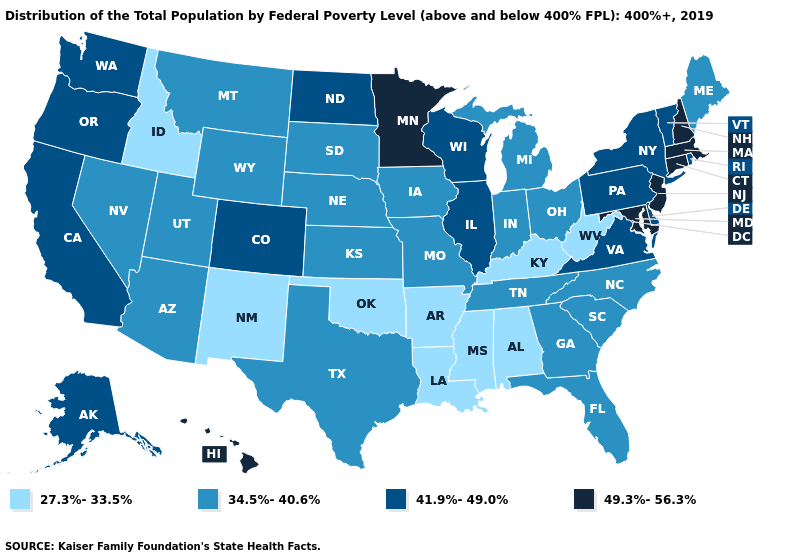Which states have the lowest value in the USA?
Keep it brief. Alabama, Arkansas, Idaho, Kentucky, Louisiana, Mississippi, New Mexico, Oklahoma, West Virginia. What is the lowest value in states that border Utah?
Give a very brief answer. 27.3%-33.5%. Among the states that border New Hampshire , which have the lowest value?
Quick response, please. Maine. What is the value of North Dakota?
Keep it brief. 41.9%-49.0%. Among the states that border Arkansas , does Missouri have the lowest value?
Keep it brief. No. Among the states that border Maryland , which have the highest value?
Answer briefly. Delaware, Pennsylvania, Virginia. What is the highest value in states that border Missouri?
Concise answer only. 41.9%-49.0%. Does the first symbol in the legend represent the smallest category?
Write a very short answer. Yes. Does Wisconsin have the same value as Pennsylvania?
Give a very brief answer. Yes. What is the lowest value in the West?
Give a very brief answer. 27.3%-33.5%. How many symbols are there in the legend?
Answer briefly. 4. Does Idaho have the same value as West Virginia?
Answer briefly. Yes. Name the states that have a value in the range 49.3%-56.3%?
Quick response, please. Connecticut, Hawaii, Maryland, Massachusetts, Minnesota, New Hampshire, New Jersey. What is the value of Nevada?
Keep it brief. 34.5%-40.6%. Does Minnesota have a lower value than West Virginia?
Give a very brief answer. No. 